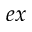<formula> <loc_0><loc_0><loc_500><loc_500>e x</formula> 